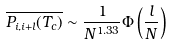Convert formula to latex. <formula><loc_0><loc_0><loc_500><loc_500>\overline { P _ { i , i + l } ( T _ { c } ) } \sim \frac { 1 } { N ^ { 1 . 3 3 } } \Phi \left ( \frac { l } { N } \right )</formula> 